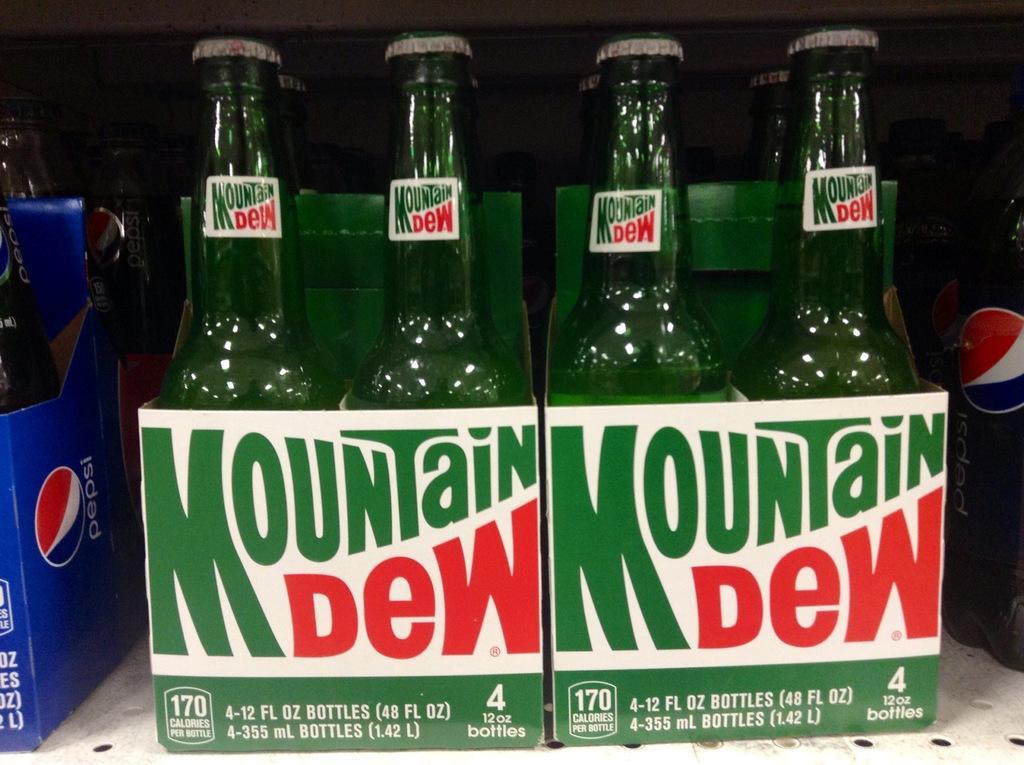In one or two sentences, can you explain what this image depicts? This bottles are highlighted in this picture. This bottles name is mountain dew. 